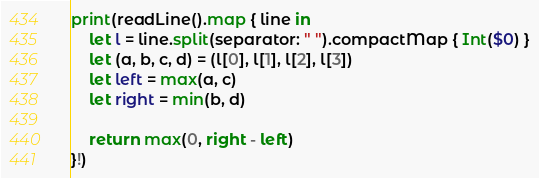Convert code to text. <code><loc_0><loc_0><loc_500><loc_500><_Swift_>print(readLine().map { line in 
    let l = line.split(separator: " ").compactMap { Int($0) }
    let (a, b, c, d) = (l[0], l[1], l[2], l[3])
    let left = max(a, c)
    let right = min(b, d)

    return max(0, right - left)
}!)</code> 